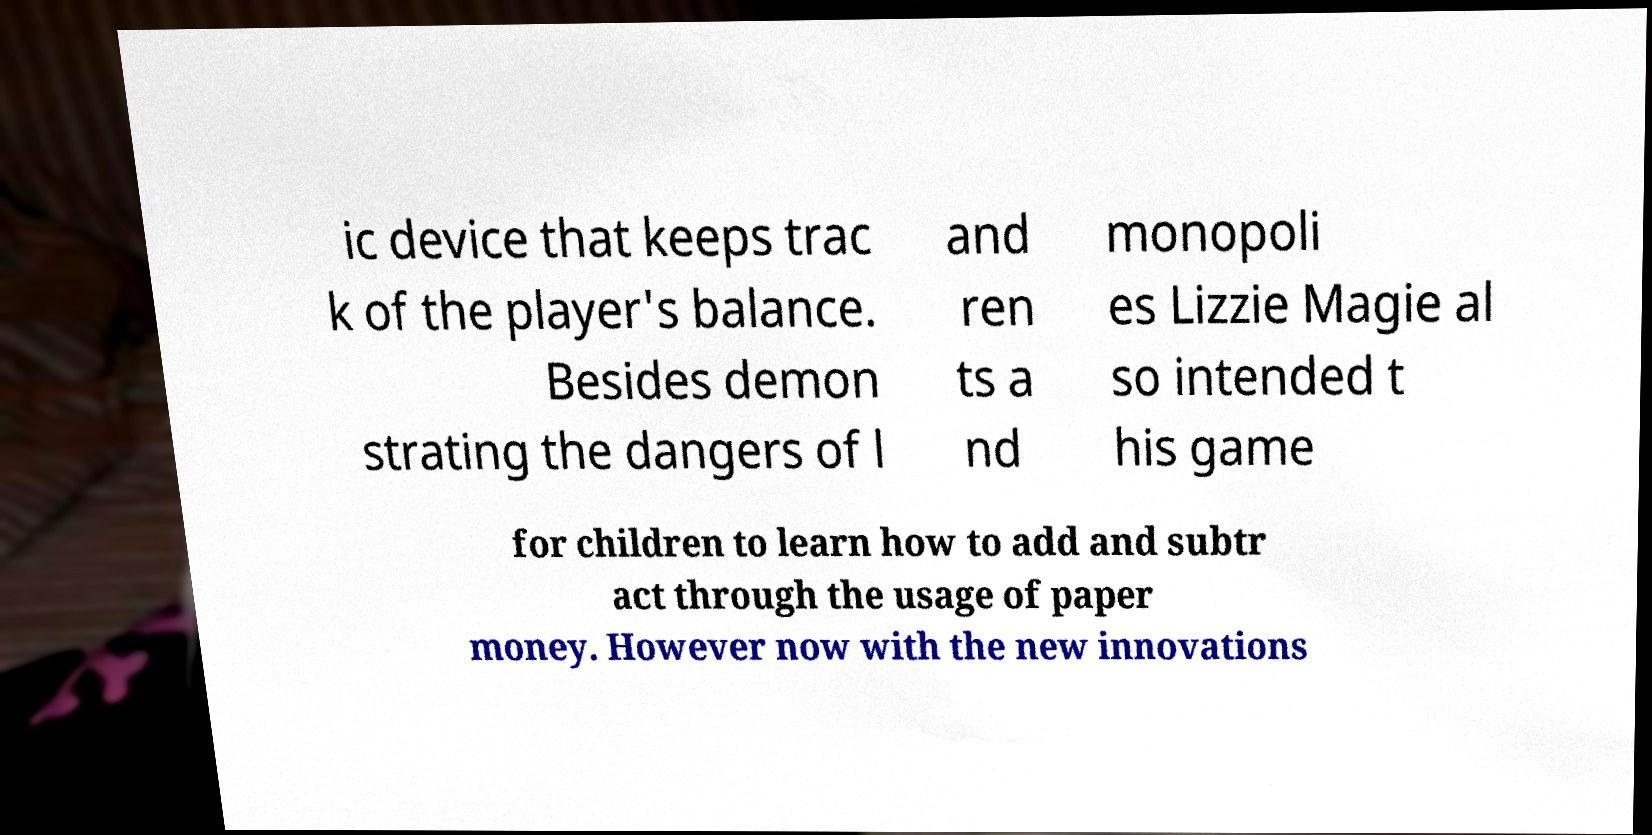Can you accurately transcribe the text from the provided image for me? ic device that keeps trac k of the player's balance. Besides demon strating the dangers of l and ren ts a nd monopoli es Lizzie Magie al so intended t his game for children to learn how to add and subtr act through the usage of paper money. However now with the new innovations 